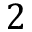<formula> <loc_0><loc_0><loc_500><loc_500>2</formula> 